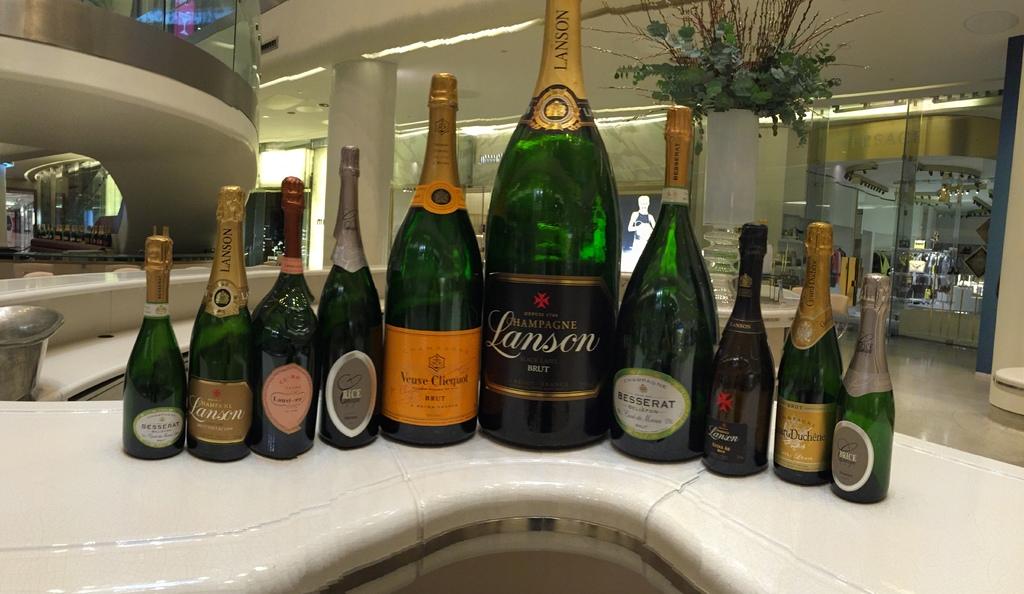What is one brand shown?
Provide a succinct answer. Lanson. 